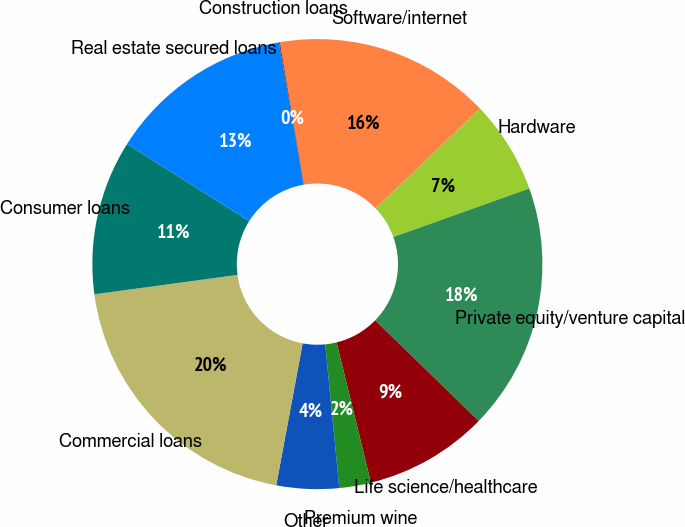Convert chart. <chart><loc_0><loc_0><loc_500><loc_500><pie_chart><fcel>Software/internet<fcel>Hardware<fcel>Private equity/venture capital<fcel>Life science/healthcare<fcel>Premium wine<fcel>Other<fcel>Commercial loans<fcel>Consumer loans<fcel>Real estate secured loans<fcel>Construction loans<nl><fcel>15.52%<fcel>6.69%<fcel>17.73%<fcel>8.9%<fcel>2.27%<fcel>4.48%<fcel>19.93%<fcel>11.1%<fcel>13.31%<fcel>0.07%<nl></chart> 